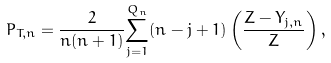<formula> <loc_0><loc_0><loc_500><loc_500>P _ { T , n } = \frac { 2 } { n ( n + 1 ) } \overset { Q _ { n } } { \underset { j = 1 } { \sum } } ( n - j + 1 ) \left ( \frac { Z - Y _ { j , n } } { Z } \right ) ,</formula> 